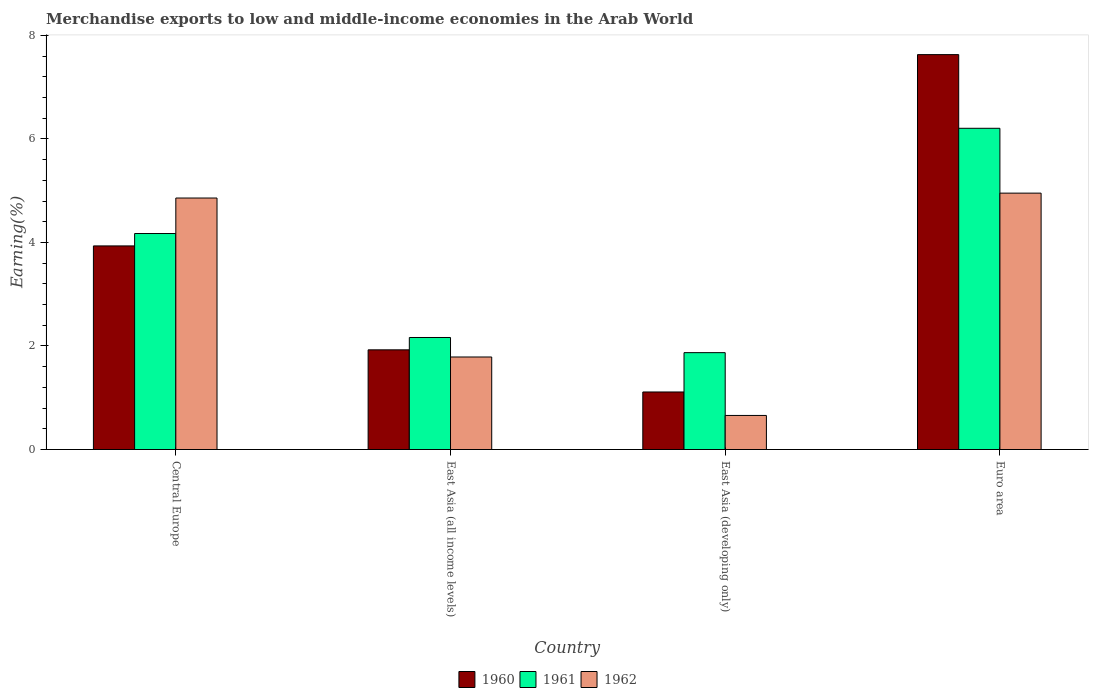How many different coloured bars are there?
Provide a short and direct response. 3. Are the number of bars per tick equal to the number of legend labels?
Provide a short and direct response. Yes. Are the number of bars on each tick of the X-axis equal?
Provide a short and direct response. Yes. How many bars are there on the 1st tick from the left?
Your answer should be compact. 3. How many bars are there on the 4th tick from the right?
Your response must be concise. 3. What is the label of the 2nd group of bars from the left?
Your answer should be very brief. East Asia (all income levels). In how many cases, is the number of bars for a given country not equal to the number of legend labels?
Make the answer very short. 0. What is the percentage of amount earned from merchandise exports in 1961 in East Asia (developing only)?
Your response must be concise. 1.87. Across all countries, what is the maximum percentage of amount earned from merchandise exports in 1960?
Offer a very short reply. 7.63. Across all countries, what is the minimum percentage of amount earned from merchandise exports in 1960?
Ensure brevity in your answer.  1.11. In which country was the percentage of amount earned from merchandise exports in 1960 maximum?
Your answer should be compact. Euro area. In which country was the percentage of amount earned from merchandise exports in 1961 minimum?
Give a very brief answer. East Asia (developing only). What is the total percentage of amount earned from merchandise exports in 1960 in the graph?
Your response must be concise. 14.6. What is the difference between the percentage of amount earned from merchandise exports in 1961 in East Asia (developing only) and that in Euro area?
Provide a short and direct response. -4.33. What is the difference between the percentage of amount earned from merchandise exports in 1961 in Central Europe and the percentage of amount earned from merchandise exports in 1962 in East Asia (developing only)?
Offer a terse response. 3.51. What is the average percentage of amount earned from merchandise exports in 1960 per country?
Provide a succinct answer. 3.65. What is the difference between the percentage of amount earned from merchandise exports of/in 1960 and percentage of amount earned from merchandise exports of/in 1961 in Central Europe?
Provide a short and direct response. -0.24. In how many countries, is the percentage of amount earned from merchandise exports in 1961 greater than 7.2 %?
Ensure brevity in your answer.  0. What is the ratio of the percentage of amount earned from merchandise exports in 1960 in Central Europe to that in East Asia (developing only)?
Keep it short and to the point. 3.54. Is the percentage of amount earned from merchandise exports in 1961 in East Asia (developing only) less than that in Euro area?
Your answer should be compact. Yes. Is the difference between the percentage of amount earned from merchandise exports in 1960 in Central Europe and East Asia (developing only) greater than the difference between the percentage of amount earned from merchandise exports in 1961 in Central Europe and East Asia (developing only)?
Keep it short and to the point. Yes. What is the difference between the highest and the second highest percentage of amount earned from merchandise exports in 1962?
Your answer should be compact. -3.16. What is the difference between the highest and the lowest percentage of amount earned from merchandise exports in 1962?
Your answer should be very brief. 4.29. In how many countries, is the percentage of amount earned from merchandise exports in 1961 greater than the average percentage of amount earned from merchandise exports in 1961 taken over all countries?
Provide a short and direct response. 2. Is the sum of the percentage of amount earned from merchandise exports in 1960 in Central Europe and East Asia (developing only) greater than the maximum percentage of amount earned from merchandise exports in 1962 across all countries?
Your answer should be compact. Yes. What does the 2nd bar from the right in East Asia (developing only) represents?
Keep it short and to the point. 1961. How many bars are there?
Your response must be concise. 12. Are all the bars in the graph horizontal?
Make the answer very short. No. How many countries are there in the graph?
Your response must be concise. 4. Are the values on the major ticks of Y-axis written in scientific E-notation?
Offer a very short reply. No. How are the legend labels stacked?
Provide a succinct answer. Horizontal. What is the title of the graph?
Ensure brevity in your answer.  Merchandise exports to low and middle-income economies in the Arab World. Does "1990" appear as one of the legend labels in the graph?
Make the answer very short. No. What is the label or title of the X-axis?
Your response must be concise. Country. What is the label or title of the Y-axis?
Give a very brief answer. Earning(%). What is the Earning(%) in 1960 in Central Europe?
Ensure brevity in your answer.  3.93. What is the Earning(%) in 1961 in Central Europe?
Make the answer very short. 4.17. What is the Earning(%) in 1962 in Central Europe?
Offer a terse response. 4.86. What is the Earning(%) of 1960 in East Asia (all income levels)?
Keep it short and to the point. 1.93. What is the Earning(%) of 1961 in East Asia (all income levels)?
Ensure brevity in your answer.  2.16. What is the Earning(%) of 1962 in East Asia (all income levels)?
Ensure brevity in your answer.  1.79. What is the Earning(%) of 1960 in East Asia (developing only)?
Ensure brevity in your answer.  1.11. What is the Earning(%) in 1961 in East Asia (developing only)?
Give a very brief answer. 1.87. What is the Earning(%) of 1962 in East Asia (developing only)?
Make the answer very short. 0.66. What is the Earning(%) in 1960 in Euro area?
Provide a short and direct response. 7.63. What is the Earning(%) in 1961 in Euro area?
Ensure brevity in your answer.  6.2. What is the Earning(%) in 1962 in Euro area?
Provide a succinct answer. 4.95. Across all countries, what is the maximum Earning(%) of 1960?
Provide a short and direct response. 7.63. Across all countries, what is the maximum Earning(%) of 1961?
Offer a very short reply. 6.2. Across all countries, what is the maximum Earning(%) in 1962?
Offer a very short reply. 4.95. Across all countries, what is the minimum Earning(%) in 1960?
Make the answer very short. 1.11. Across all countries, what is the minimum Earning(%) of 1961?
Make the answer very short. 1.87. Across all countries, what is the minimum Earning(%) of 1962?
Keep it short and to the point. 0.66. What is the total Earning(%) in 1960 in the graph?
Your answer should be very brief. 14.6. What is the total Earning(%) in 1961 in the graph?
Make the answer very short. 14.41. What is the total Earning(%) of 1962 in the graph?
Ensure brevity in your answer.  12.25. What is the difference between the Earning(%) in 1960 in Central Europe and that in East Asia (all income levels)?
Provide a succinct answer. 2.01. What is the difference between the Earning(%) of 1961 in Central Europe and that in East Asia (all income levels)?
Make the answer very short. 2.01. What is the difference between the Earning(%) in 1962 in Central Europe and that in East Asia (all income levels)?
Provide a short and direct response. 3.07. What is the difference between the Earning(%) in 1960 in Central Europe and that in East Asia (developing only)?
Offer a very short reply. 2.82. What is the difference between the Earning(%) of 1961 in Central Europe and that in East Asia (developing only)?
Your answer should be compact. 2.3. What is the difference between the Earning(%) in 1962 in Central Europe and that in East Asia (developing only)?
Give a very brief answer. 4.2. What is the difference between the Earning(%) of 1960 in Central Europe and that in Euro area?
Make the answer very short. -3.69. What is the difference between the Earning(%) of 1961 in Central Europe and that in Euro area?
Provide a succinct answer. -2.03. What is the difference between the Earning(%) in 1962 in Central Europe and that in Euro area?
Your response must be concise. -0.09. What is the difference between the Earning(%) in 1960 in East Asia (all income levels) and that in East Asia (developing only)?
Keep it short and to the point. 0.81. What is the difference between the Earning(%) of 1961 in East Asia (all income levels) and that in East Asia (developing only)?
Make the answer very short. 0.29. What is the difference between the Earning(%) in 1962 in East Asia (all income levels) and that in East Asia (developing only)?
Give a very brief answer. 1.13. What is the difference between the Earning(%) in 1960 in East Asia (all income levels) and that in Euro area?
Your answer should be very brief. -5.7. What is the difference between the Earning(%) of 1961 in East Asia (all income levels) and that in Euro area?
Provide a succinct answer. -4.04. What is the difference between the Earning(%) in 1962 in East Asia (all income levels) and that in Euro area?
Provide a succinct answer. -3.16. What is the difference between the Earning(%) in 1960 in East Asia (developing only) and that in Euro area?
Your answer should be compact. -6.52. What is the difference between the Earning(%) of 1961 in East Asia (developing only) and that in Euro area?
Your answer should be compact. -4.33. What is the difference between the Earning(%) in 1962 in East Asia (developing only) and that in Euro area?
Give a very brief answer. -4.29. What is the difference between the Earning(%) of 1960 in Central Europe and the Earning(%) of 1961 in East Asia (all income levels)?
Make the answer very short. 1.77. What is the difference between the Earning(%) of 1960 in Central Europe and the Earning(%) of 1962 in East Asia (all income levels)?
Make the answer very short. 2.15. What is the difference between the Earning(%) in 1961 in Central Europe and the Earning(%) in 1962 in East Asia (all income levels)?
Ensure brevity in your answer.  2.38. What is the difference between the Earning(%) of 1960 in Central Europe and the Earning(%) of 1961 in East Asia (developing only)?
Your response must be concise. 2.06. What is the difference between the Earning(%) of 1960 in Central Europe and the Earning(%) of 1962 in East Asia (developing only)?
Provide a short and direct response. 3.27. What is the difference between the Earning(%) of 1961 in Central Europe and the Earning(%) of 1962 in East Asia (developing only)?
Make the answer very short. 3.51. What is the difference between the Earning(%) of 1960 in Central Europe and the Earning(%) of 1961 in Euro area?
Make the answer very short. -2.27. What is the difference between the Earning(%) in 1960 in Central Europe and the Earning(%) in 1962 in Euro area?
Your answer should be compact. -1.02. What is the difference between the Earning(%) of 1961 in Central Europe and the Earning(%) of 1962 in Euro area?
Your answer should be compact. -0.78. What is the difference between the Earning(%) in 1960 in East Asia (all income levels) and the Earning(%) in 1961 in East Asia (developing only)?
Ensure brevity in your answer.  0.05. What is the difference between the Earning(%) of 1960 in East Asia (all income levels) and the Earning(%) of 1962 in East Asia (developing only)?
Your response must be concise. 1.27. What is the difference between the Earning(%) of 1961 in East Asia (all income levels) and the Earning(%) of 1962 in East Asia (developing only)?
Ensure brevity in your answer.  1.51. What is the difference between the Earning(%) in 1960 in East Asia (all income levels) and the Earning(%) in 1961 in Euro area?
Offer a very short reply. -4.28. What is the difference between the Earning(%) in 1960 in East Asia (all income levels) and the Earning(%) in 1962 in Euro area?
Offer a terse response. -3.03. What is the difference between the Earning(%) of 1961 in East Asia (all income levels) and the Earning(%) of 1962 in Euro area?
Ensure brevity in your answer.  -2.79. What is the difference between the Earning(%) in 1960 in East Asia (developing only) and the Earning(%) in 1961 in Euro area?
Offer a terse response. -5.09. What is the difference between the Earning(%) in 1960 in East Asia (developing only) and the Earning(%) in 1962 in Euro area?
Ensure brevity in your answer.  -3.84. What is the difference between the Earning(%) in 1961 in East Asia (developing only) and the Earning(%) in 1962 in Euro area?
Ensure brevity in your answer.  -3.08. What is the average Earning(%) in 1960 per country?
Keep it short and to the point. 3.65. What is the average Earning(%) in 1961 per country?
Provide a short and direct response. 3.6. What is the average Earning(%) of 1962 per country?
Your answer should be very brief. 3.06. What is the difference between the Earning(%) of 1960 and Earning(%) of 1961 in Central Europe?
Make the answer very short. -0.24. What is the difference between the Earning(%) in 1960 and Earning(%) in 1962 in Central Europe?
Ensure brevity in your answer.  -0.92. What is the difference between the Earning(%) in 1961 and Earning(%) in 1962 in Central Europe?
Offer a terse response. -0.69. What is the difference between the Earning(%) of 1960 and Earning(%) of 1961 in East Asia (all income levels)?
Provide a short and direct response. -0.24. What is the difference between the Earning(%) in 1960 and Earning(%) in 1962 in East Asia (all income levels)?
Offer a terse response. 0.14. What is the difference between the Earning(%) of 1961 and Earning(%) of 1962 in East Asia (all income levels)?
Your answer should be compact. 0.38. What is the difference between the Earning(%) in 1960 and Earning(%) in 1961 in East Asia (developing only)?
Make the answer very short. -0.76. What is the difference between the Earning(%) in 1960 and Earning(%) in 1962 in East Asia (developing only)?
Provide a short and direct response. 0.45. What is the difference between the Earning(%) of 1961 and Earning(%) of 1962 in East Asia (developing only)?
Offer a very short reply. 1.21. What is the difference between the Earning(%) of 1960 and Earning(%) of 1961 in Euro area?
Ensure brevity in your answer.  1.42. What is the difference between the Earning(%) of 1960 and Earning(%) of 1962 in Euro area?
Keep it short and to the point. 2.68. What is the difference between the Earning(%) of 1961 and Earning(%) of 1962 in Euro area?
Provide a succinct answer. 1.25. What is the ratio of the Earning(%) in 1960 in Central Europe to that in East Asia (all income levels)?
Provide a succinct answer. 2.04. What is the ratio of the Earning(%) in 1961 in Central Europe to that in East Asia (all income levels)?
Your answer should be very brief. 1.93. What is the ratio of the Earning(%) of 1962 in Central Europe to that in East Asia (all income levels)?
Make the answer very short. 2.72. What is the ratio of the Earning(%) in 1960 in Central Europe to that in East Asia (developing only)?
Keep it short and to the point. 3.54. What is the ratio of the Earning(%) of 1961 in Central Europe to that in East Asia (developing only)?
Ensure brevity in your answer.  2.23. What is the ratio of the Earning(%) of 1962 in Central Europe to that in East Asia (developing only)?
Offer a terse response. 7.38. What is the ratio of the Earning(%) of 1960 in Central Europe to that in Euro area?
Your answer should be compact. 0.52. What is the ratio of the Earning(%) of 1961 in Central Europe to that in Euro area?
Your response must be concise. 0.67. What is the ratio of the Earning(%) of 1962 in Central Europe to that in Euro area?
Keep it short and to the point. 0.98. What is the ratio of the Earning(%) in 1960 in East Asia (all income levels) to that in East Asia (developing only)?
Give a very brief answer. 1.73. What is the ratio of the Earning(%) in 1961 in East Asia (all income levels) to that in East Asia (developing only)?
Your answer should be very brief. 1.16. What is the ratio of the Earning(%) of 1962 in East Asia (all income levels) to that in East Asia (developing only)?
Keep it short and to the point. 2.72. What is the ratio of the Earning(%) in 1960 in East Asia (all income levels) to that in Euro area?
Provide a short and direct response. 0.25. What is the ratio of the Earning(%) in 1961 in East Asia (all income levels) to that in Euro area?
Offer a very short reply. 0.35. What is the ratio of the Earning(%) in 1962 in East Asia (all income levels) to that in Euro area?
Offer a terse response. 0.36. What is the ratio of the Earning(%) in 1960 in East Asia (developing only) to that in Euro area?
Offer a very short reply. 0.15. What is the ratio of the Earning(%) of 1961 in East Asia (developing only) to that in Euro area?
Offer a terse response. 0.3. What is the ratio of the Earning(%) in 1962 in East Asia (developing only) to that in Euro area?
Provide a short and direct response. 0.13. What is the difference between the highest and the second highest Earning(%) in 1960?
Your answer should be compact. 3.69. What is the difference between the highest and the second highest Earning(%) of 1961?
Make the answer very short. 2.03. What is the difference between the highest and the second highest Earning(%) of 1962?
Your response must be concise. 0.09. What is the difference between the highest and the lowest Earning(%) in 1960?
Your answer should be compact. 6.52. What is the difference between the highest and the lowest Earning(%) of 1961?
Your answer should be very brief. 4.33. What is the difference between the highest and the lowest Earning(%) of 1962?
Provide a succinct answer. 4.29. 